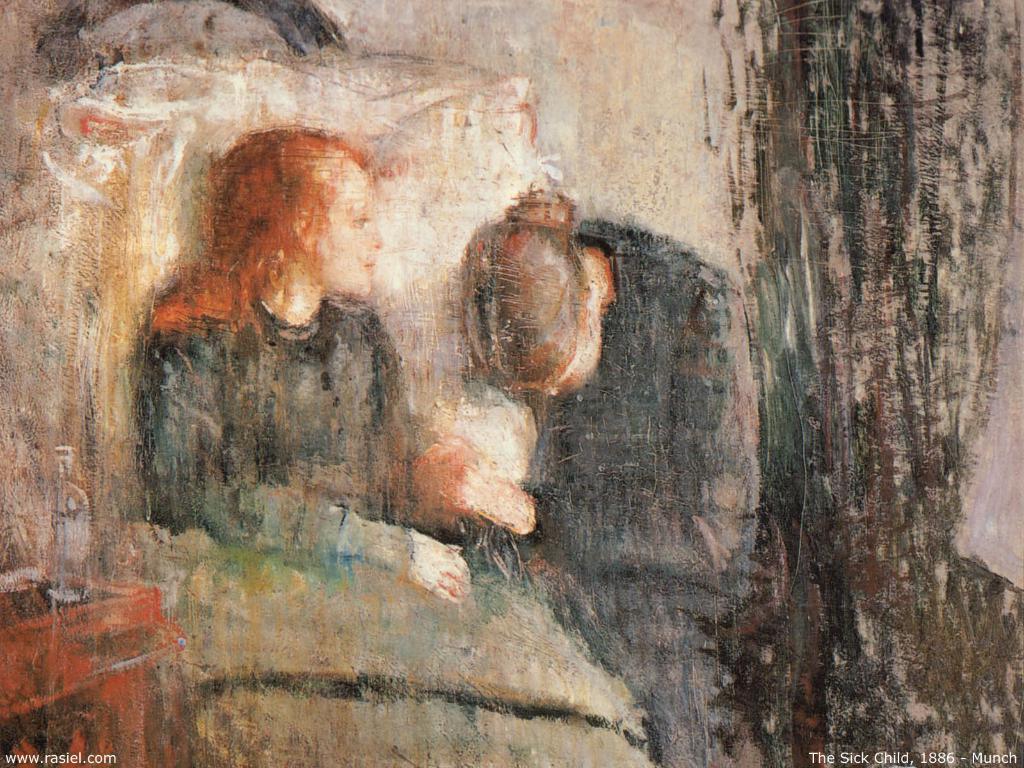Describe this image in one or two sentences. The picture is a painting. In the painting there are two persons. On the left there is a desk, on the desk there is a bottle. 